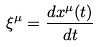<formula> <loc_0><loc_0><loc_500><loc_500>\xi ^ { \mu } = \frac { d x ^ { \mu } ( t ) } { d t }</formula> 